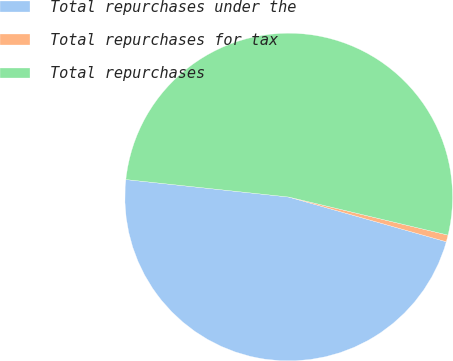Convert chart. <chart><loc_0><loc_0><loc_500><loc_500><pie_chart><fcel>Total repurchases under the<fcel>Total repurchases for tax<fcel>Total repurchases<nl><fcel>47.3%<fcel>0.67%<fcel>52.03%<nl></chart> 